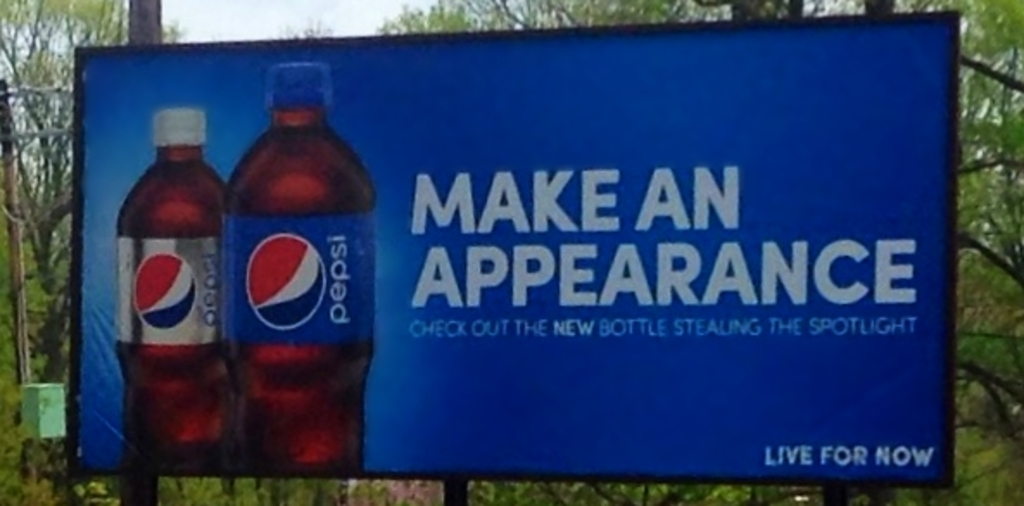How might the location of this billboard influence its effectiveness? Placing the billboard in a lush green area potentially frequented by drivers or passersby can significantly boost its effectiveness. The natural backdrop ensures that the vivid colors of the billboard stand more pronounced, capturing attention effortlessly. Moreover, if this location is on a frequent route for commuters, the repetitive exposure could reinforce brand recall and persuade purchasing decisions. 